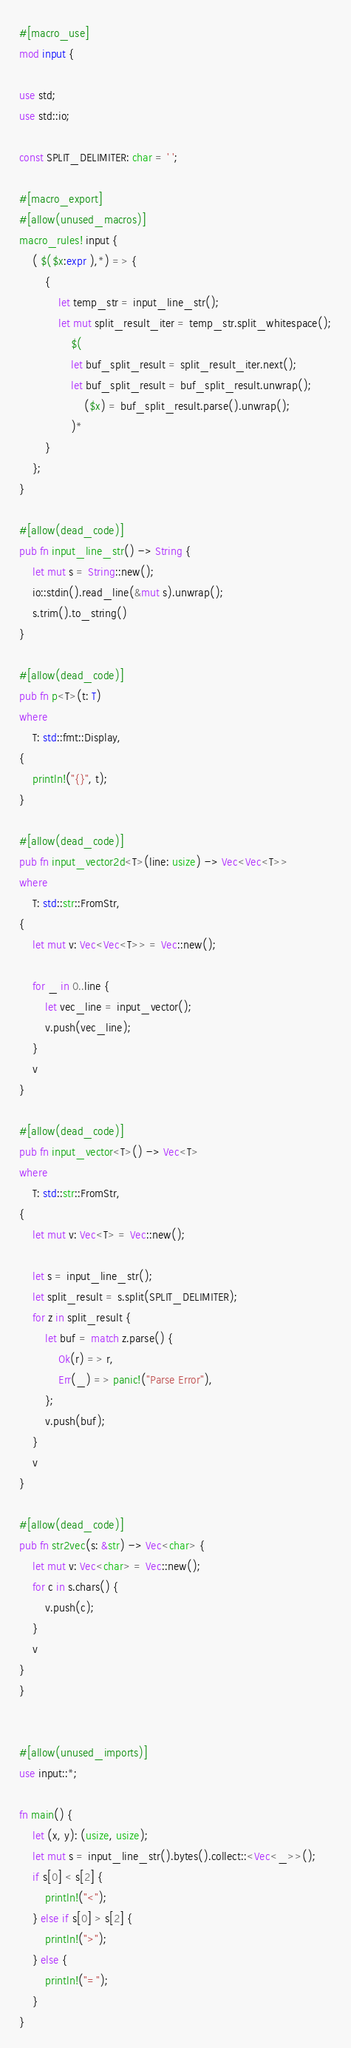<code> <loc_0><loc_0><loc_500><loc_500><_Rust_>#[macro_use]
mod input {

use std;
use std::io;

const SPLIT_DELIMITER: char = ' ';

#[macro_export]
#[allow(unused_macros)]
macro_rules! input {
    ( $($x:expr ),*) => {
        {
            let temp_str = input_line_str();
            let mut split_result_iter = temp_str.split_whitespace();
                $(
                let buf_split_result = split_result_iter.next();
                let buf_split_result = buf_split_result.unwrap();
                    ($x) = buf_split_result.parse().unwrap();
                )*
        }
    };
}

#[allow(dead_code)]
pub fn input_line_str() -> String {
    let mut s = String::new();
    io::stdin().read_line(&mut s).unwrap();
    s.trim().to_string()
}

#[allow(dead_code)]
pub fn p<T>(t: T)
where
    T: std::fmt::Display,
{
    println!("{}", t);
}

#[allow(dead_code)]
pub fn input_vector2d<T>(line: usize) -> Vec<Vec<T>>
where
    T: std::str::FromStr,
{
    let mut v: Vec<Vec<T>> = Vec::new();

    for _ in 0..line {
        let vec_line = input_vector();
        v.push(vec_line);
    }
    v
}

#[allow(dead_code)]
pub fn input_vector<T>() -> Vec<T>
where
    T: std::str::FromStr,
{
    let mut v: Vec<T> = Vec::new();

    let s = input_line_str();
    let split_result = s.split(SPLIT_DELIMITER);
    for z in split_result {
        let buf = match z.parse() {
            Ok(r) => r,
            Err(_) => panic!("Parse Error"),
        };
        v.push(buf);
    }
    v
}

#[allow(dead_code)]
pub fn str2vec(s: &str) -> Vec<char> {
    let mut v: Vec<char> = Vec::new();
    for c in s.chars() {
        v.push(c);
    }
    v
}
}


#[allow(unused_imports)]
use input::*;

fn main() {
    let (x, y): (usize, usize);
    let mut s = input_line_str().bytes().collect::<Vec<_>>();
    if s[0] < s[2] {
        println!("<");
    } else if s[0] > s[2] {
        println!(">");
    } else {
        println!("=");
    }
}</code> 